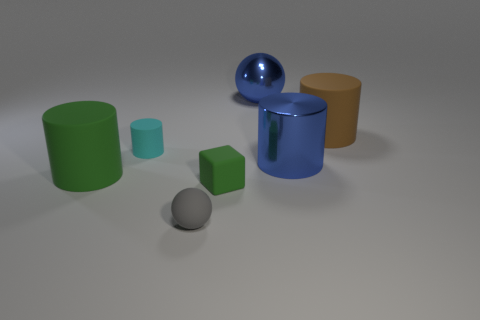Is there a small matte cube of the same color as the matte ball?
Make the answer very short. No. Are any gray metallic cubes visible?
Your response must be concise. No. Is the brown rubber thing the same shape as the small gray thing?
Your answer should be very brief. No. How many small things are either gray spheres or cyan cylinders?
Provide a short and direct response. 2. What is the color of the small matte sphere?
Provide a succinct answer. Gray. What shape is the green matte thing that is in front of the big rubber cylinder in front of the brown object?
Ensure brevity in your answer.  Cube. Is there a small blue thing made of the same material as the large sphere?
Your answer should be compact. No. There is a green thing behind the green cube; is it the same size as the shiny sphere?
Keep it short and to the point. Yes. What number of gray objects are either blocks or small matte balls?
Keep it short and to the point. 1. What is the material of the ball in front of the tiny cube?
Provide a short and direct response. Rubber. 